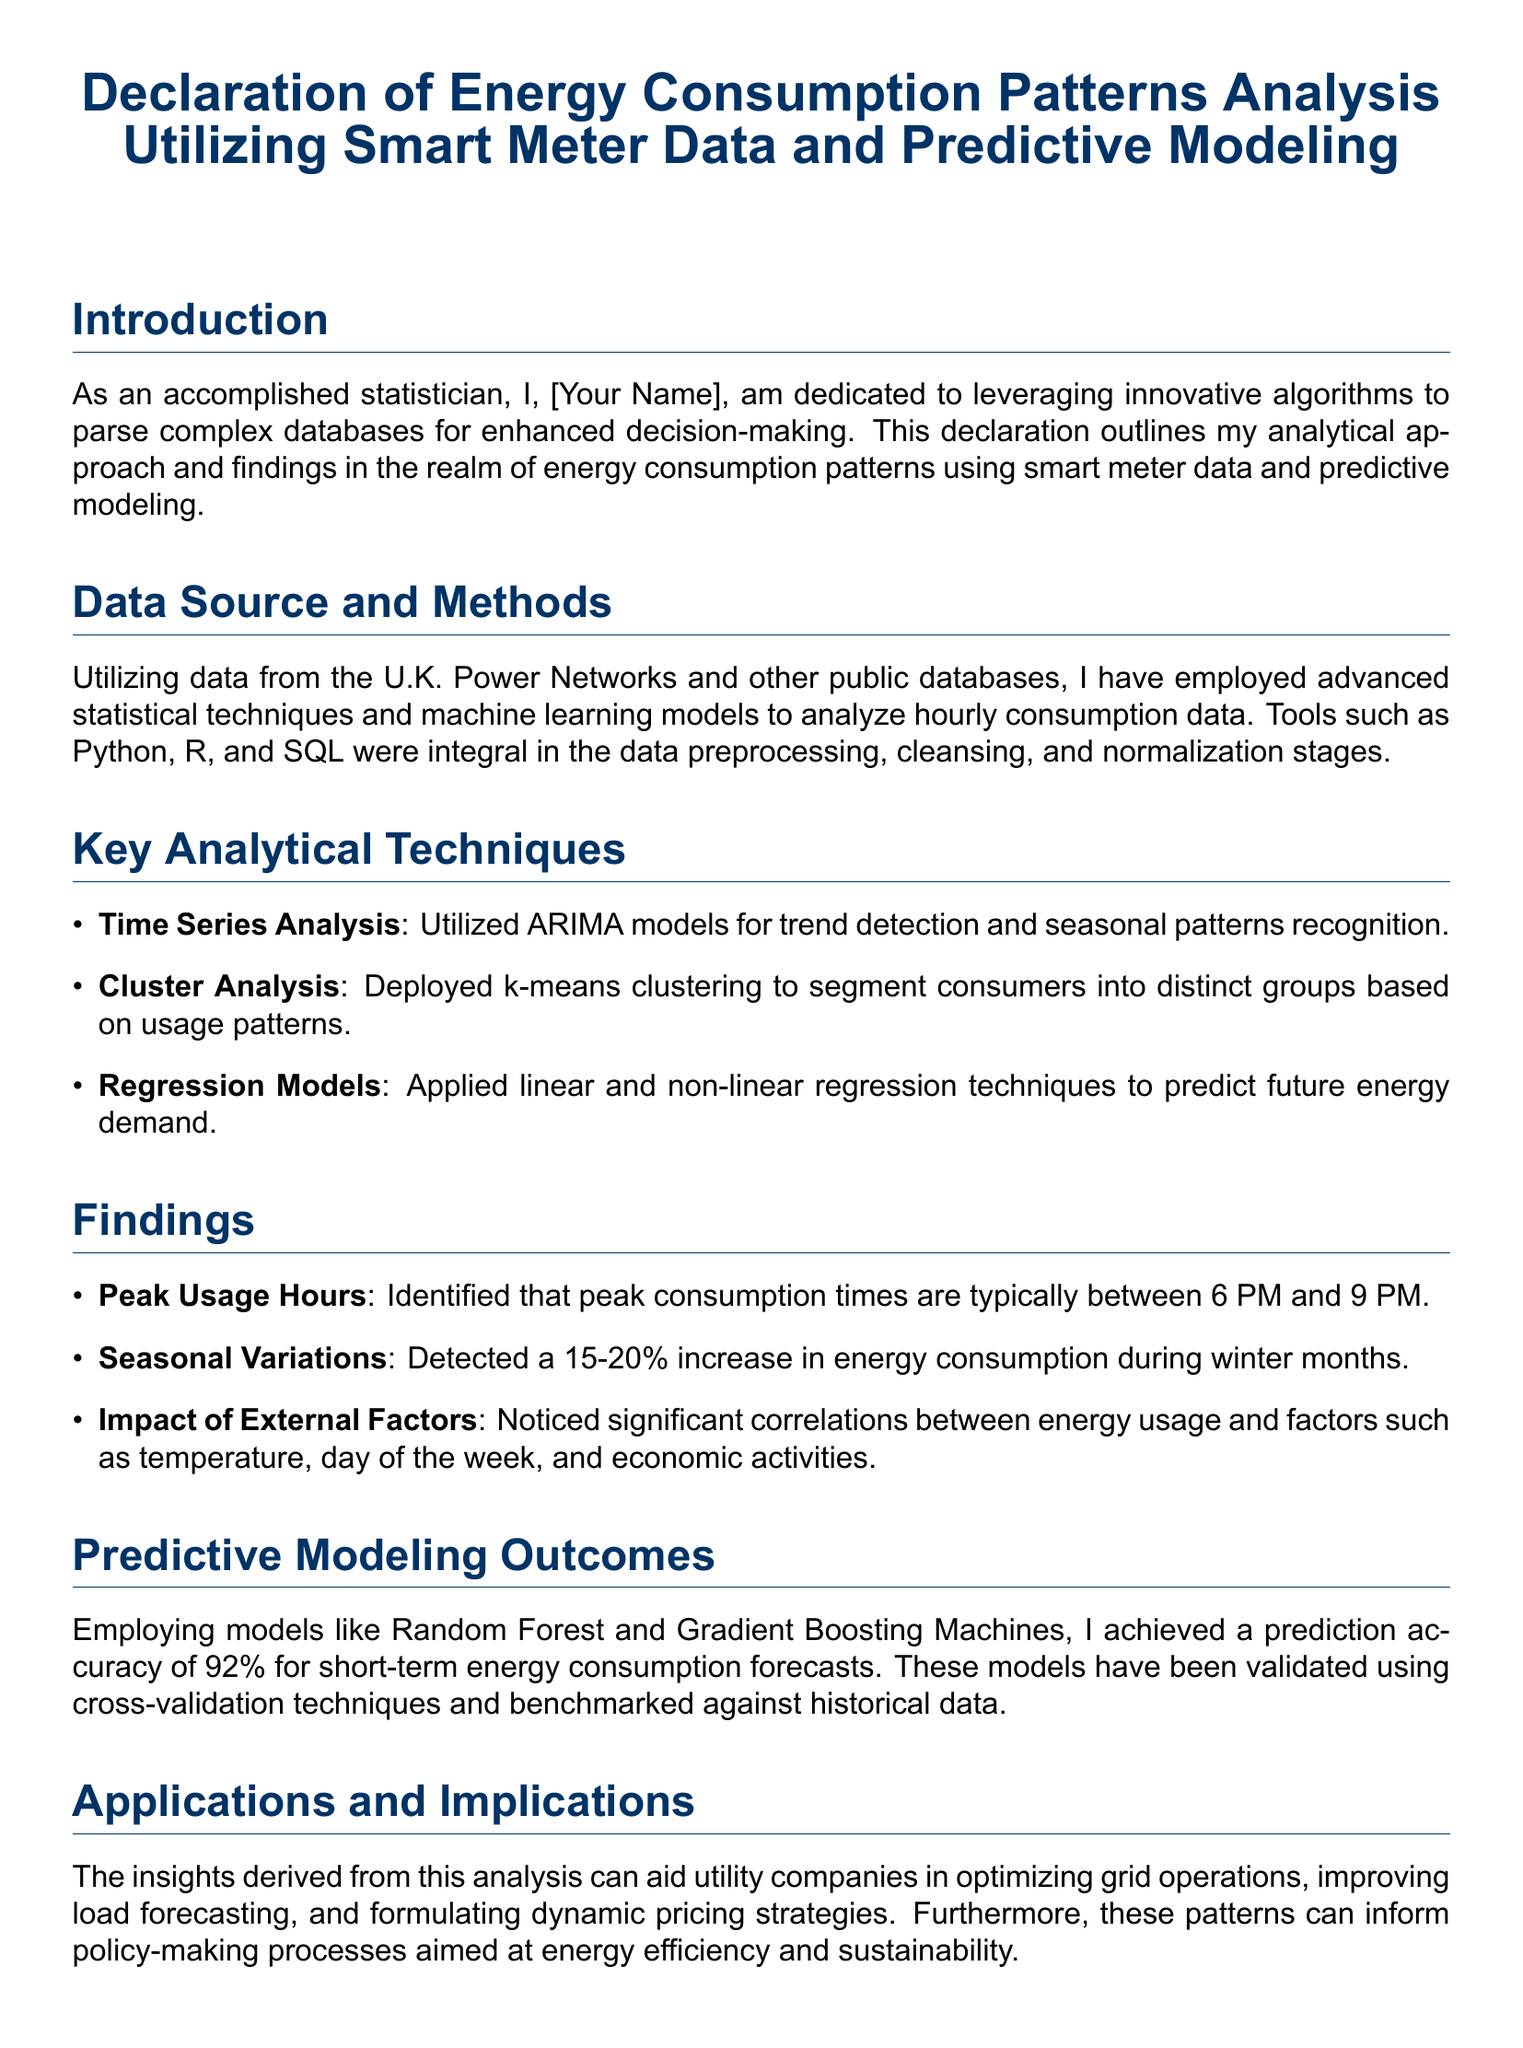What is the peak consumption time? The document specifies that peak consumption times are typically between 6 PM and 9 PM.
Answer: 6 PM and 9 PM What percentage increase in energy consumption was detected during winter months? The declaration mentions a 15-20% increase in energy consumption during winter months.
Answer: 15-20% Which models were employed for predictive modeling? The document lists Random Forest and Gradient Boosting Machines as the models used for predictive modeling.
Answer: Random Forest and Gradient Boosting Machines What statistical technique was used for trend detection? The declaration states that ARIMA models were utilized for trend detection and seasonal patterns recognition.
Answer: ARIMA models What is the prediction accuracy achieved for short-term energy consumption forecasts? The document reports a prediction accuracy of 92% for short-term energy consumption forecasts.
Answer: 92% What data sources were utilized in the analysis? The declaration mentions that data from the U.K. Power Networks and other public databases were utilized.
Answer: U.K. Power Networks and other public databases What is the main purpose of the declared analysis? The document emphasizes that the analysis aims at enhancing decision-making regarding energy consumption patterns.
Answer: Enhancing decision-making Who authored the declaration? The document indicates that the declaration is authored by an accomplished statistician, referred to as "[Your Name]."
Answer: [Your Name] What type of analysis was conducted on the energy consumption data? The declaration outlines that key analytical techniques included Time Series Analysis, Cluster Analysis, and Regression Models.
Answer: Time Series Analysis, Cluster Analysis, Regression Models 